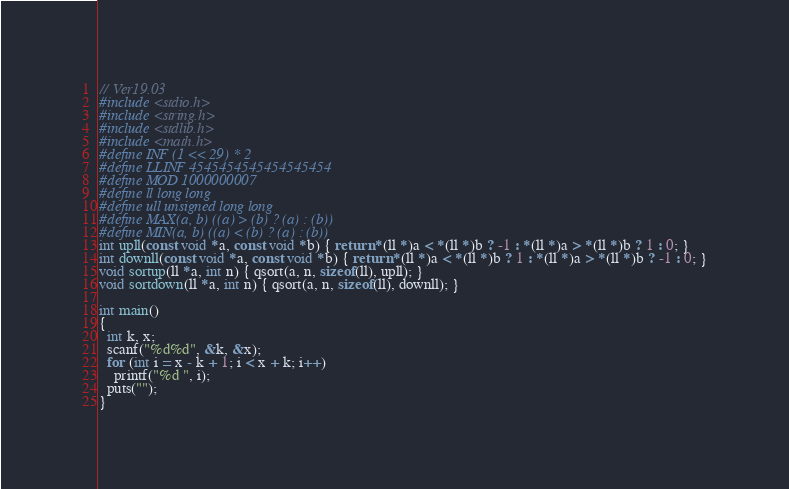Convert code to text. <code><loc_0><loc_0><loc_500><loc_500><_C_>// Ver19.03
#include <stdio.h>
#include <string.h>
#include <stdlib.h>
#include <math.h>
#define INF (1 << 29) * 2
#define LLINF 4545454545454545454
#define MOD 1000000007
#define ll long long
#define ull unsigned long long
#define MAX(a, b) ((a) > (b) ? (a) : (b))
#define MIN(a, b) ((a) < (b) ? (a) : (b))
int upll(const void *a, const void *b) { return *(ll *)a < *(ll *)b ? -1 : *(ll *)a > *(ll *)b ? 1 : 0; }
int downll(const void *a, const void *b) { return *(ll *)a < *(ll *)b ? 1 : *(ll *)a > *(ll *)b ? -1 : 0; }
void sortup(ll *a, int n) { qsort(a, n, sizeof(ll), upll); }
void sortdown(ll *a, int n) { qsort(a, n, sizeof(ll), downll); }

int main()
{
  int k, x;
  scanf("%d%d", &k, &x);
  for (int i = x - k + 1; i < x + k; i++)
    printf("%d ", i);
  puts("");
}</code> 